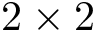Convert formula to latex. <formula><loc_0><loc_0><loc_500><loc_500>2 \times 2</formula> 